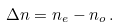<formula> <loc_0><loc_0><loc_500><loc_500>\Delta n = n _ { e } - n _ { o } \, .</formula> 